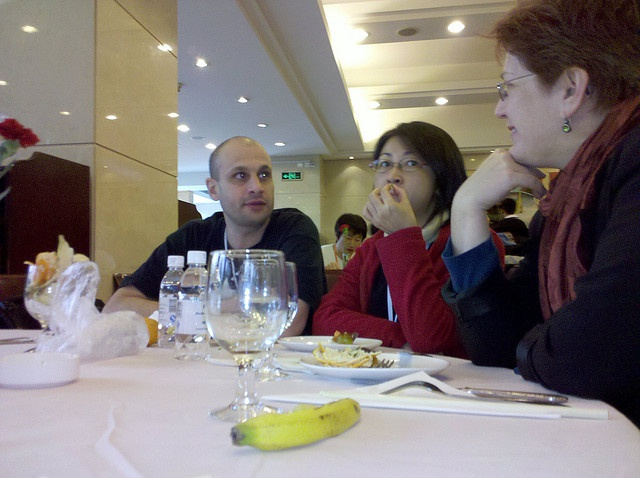Describe the objects in this image and their specific colors. I can see people in darkgray, black, maroon, and gray tones, dining table in darkgray and lightgray tones, people in darkgray, maroon, black, and gray tones, people in darkgray, black, and gray tones, and banana in darkgray, olive, and khaki tones in this image. 